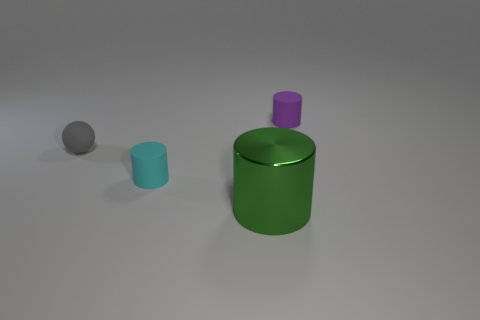Is there anything else that is the same size as the metal object?
Offer a very short reply. No. Is the number of matte things that are behind the big object greater than the number of big blue blocks?
Offer a very short reply. Yes. Are any large metal cylinders visible?
Ensure brevity in your answer.  Yes. What number of rubber balls are the same size as the gray matte object?
Offer a terse response. 0. Are there more green cylinders in front of the tiny gray matte object than gray rubber balls that are in front of the large green cylinder?
Provide a short and direct response. Yes. There is a purple cylinder that is the same size as the gray sphere; what material is it?
Keep it short and to the point. Rubber. What shape is the gray object?
Ensure brevity in your answer.  Sphere. How many gray things are large cylinders or tiny rubber things?
Offer a very short reply. 1. There is a ball that is the same material as the tiny cyan cylinder; what size is it?
Keep it short and to the point. Small. Is the material of the small thing to the left of the tiny cyan rubber cylinder the same as the green cylinder to the right of the tiny gray thing?
Your answer should be compact. No. 